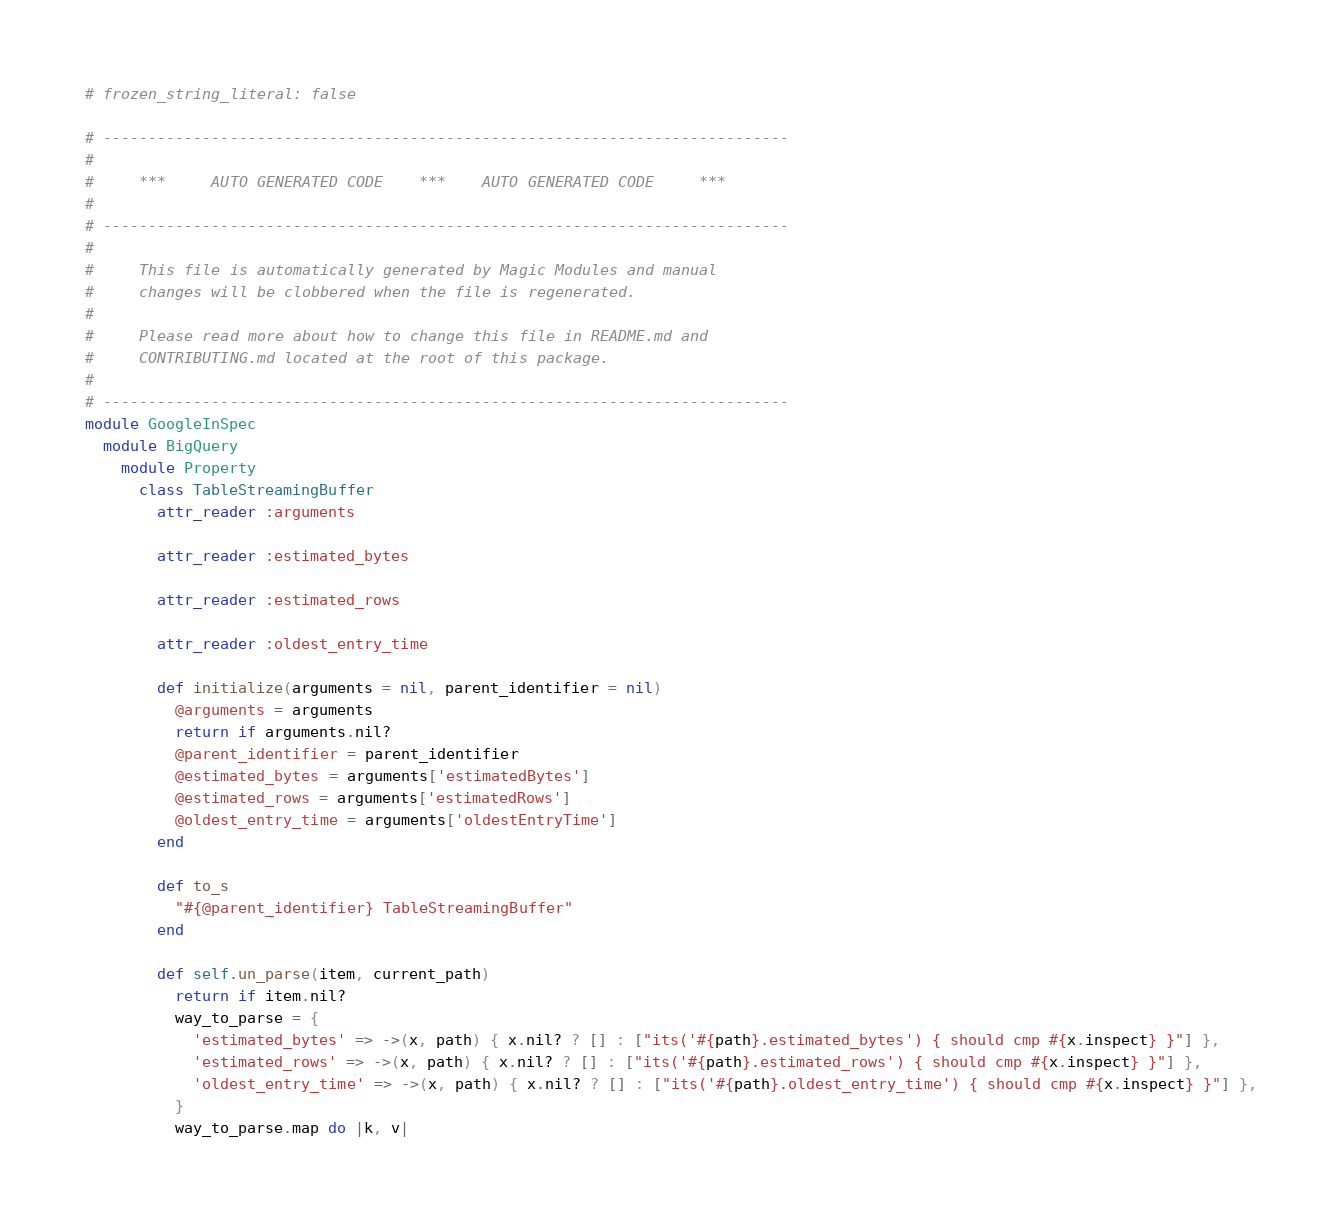<code> <loc_0><loc_0><loc_500><loc_500><_Ruby_># frozen_string_literal: false

# ----------------------------------------------------------------------------
#
#     ***     AUTO GENERATED CODE    ***    AUTO GENERATED CODE     ***
#
# ----------------------------------------------------------------------------
#
#     This file is automatically generated by Magic Modules and manual
#     changes will be clobbered when the file is regenerated.
#
#     Please read more about how to change this file in README.md and
#     CONTRIBUTING.md located at the root of this package.
#
# ----------------------------------------------------------------------------
module GoogleInSpec
  module BigQuery
    module Property
      class TableStreamingBuffer
        attr_reader :arguments

        attr_reader :estimated_bytes

        attr_reader :estimated_rows

        attr_reader :oldest_entry_time

        def initialize(arguments = nil, parent_identifier = nil)
          @arguments = arguments
          return if arguments.nil?
          @parent_identifier = parent_identifier
          @estimated_bytes = arguments['estimatedBytes']
          @estimated_rows = arguments['estimatedRows']
          @oldest_entry_time = arguments['oldestEntryTime']
        end

        def to_s
          "#{@parent_identifier} TableStreamingBuffer"
        end

        def self.un_parse(item, current_path)
          return if item.nil?
          way_to_parse = {
            'estimated_bytes' => ->(x, path) { x.nil? ? [] : ["its('#{path}.estimated_bytes') { should cmp #{x.inspect} }"] },
            'estimated_rows' => ->(x, path) { x.nil? ? [] : ["its('#{path}.estimated_rows') { should cmp #{x.inspect} }"] },
            'oldest_entry_time' => ->(x, path) { x.nil? ? [] : ["its('#{path}.oldest_entry_time') { should cmp #{x.inspect} }"] },
          }
          way_to_parse.map do |k, v|</code> 